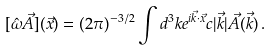Convert formula to latex. <formula><loc_0><loc_0><loc_500><loc_500>[ \hat { \omega } \vec { A } ] ( \vec { x } ) = ( 2 \pi ) ^ { - 3 / 2 } \int d ^ { 3 } k e ^ { i \vec { k } \cdot \vec { x } } c | \vec { k } | \vec { A } ( \vec { k } ) \, .</formula> 